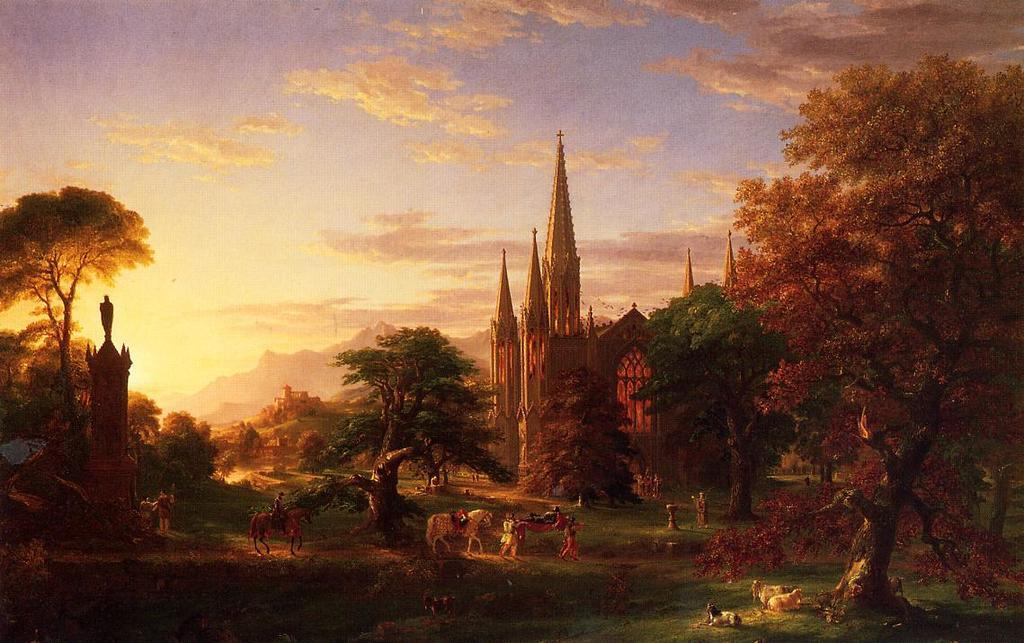What types of living beings are present in the image? There are animals and people in the image. What structures can be seen in the image? There are castles in the image. What type of vegetation is present in the image? There are trees and grass in the image. What geographical features are visible in the image? There are mountains in the image. How would you describe the weather in the image? The sky is cloudy in the image. What type of cup is being used by the aunt during recess in the image? There is no cup, aunt, or recess present in the image. 